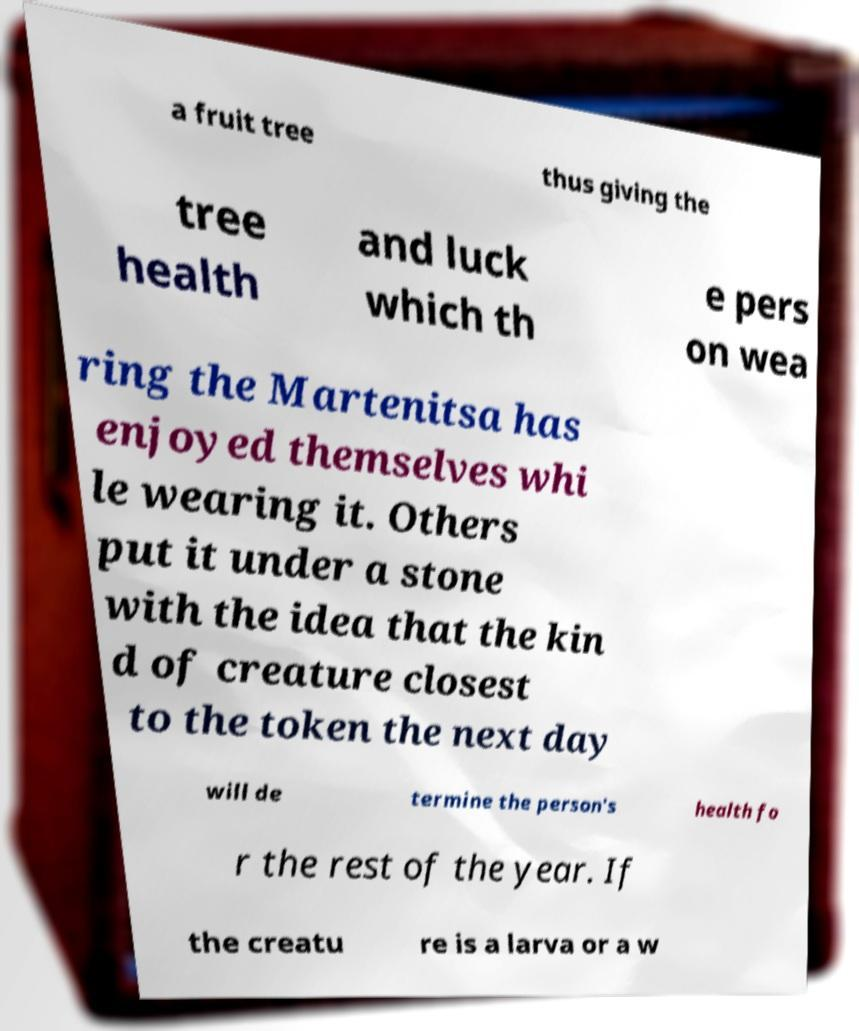Please read and relay the text visible in this image. What does it say? a fruit tree thus giving the tree health and luck which th e pers on wea ring the Martenitsa has enjoyed themselves whi le wearing it. Others put it under a stone with the idea that the kin d of creature closest to the token the next day will de termine the person's health fo r the rest of the year. If the creatu re is a larva or a w 